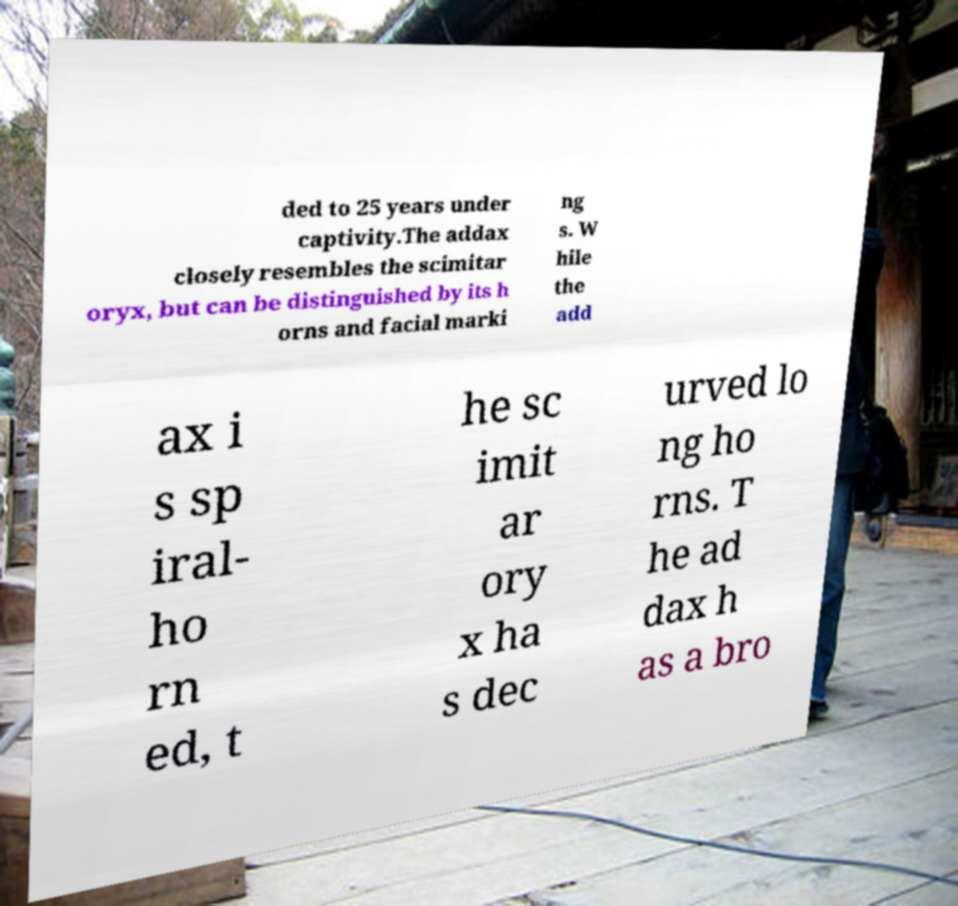Can you read and provide the text displayed in the image?This photo seems to have some interesting text. Can you extract and type it out for me? ded to 25 years under captivity.The addax closely resembles the scimitar oryx, but can be distinguished by its h orns and facial marki ng s. W hile the add ax i s sp iral- ho rn ed, t he sc imit ar ory x ha s dec urved lo ng ho rns. T he ad dax h as a bro 